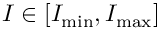<formula> <loc_0><loc_0><loc_500><loc_500>I \in [ I _ { \min } , I _ { \max } ]</formula> 